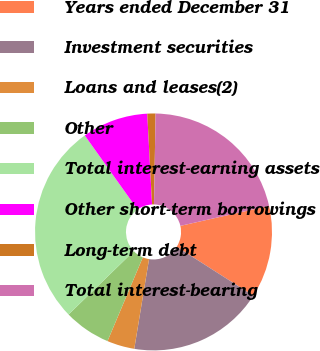<chart> <loc_0><loc_0><loc_500><loc_500><pie_chart><fcel>Years ended December 31<fcel>Investment securities<fcel>Loans and leases(2)<fcel>Other<fcel>Total interest-earning assets<fcel>Other short-term borrowings<fcel>Long-term debt<fcel>Total interest-bearing<nl><fcel>12.59%<fcel>18.55%<fcel>3.75%<fcel>6.38%<fcel>27.42%<fcel>9.01%<fcel>1.12%<fcel>21.18%<nl></chart> 